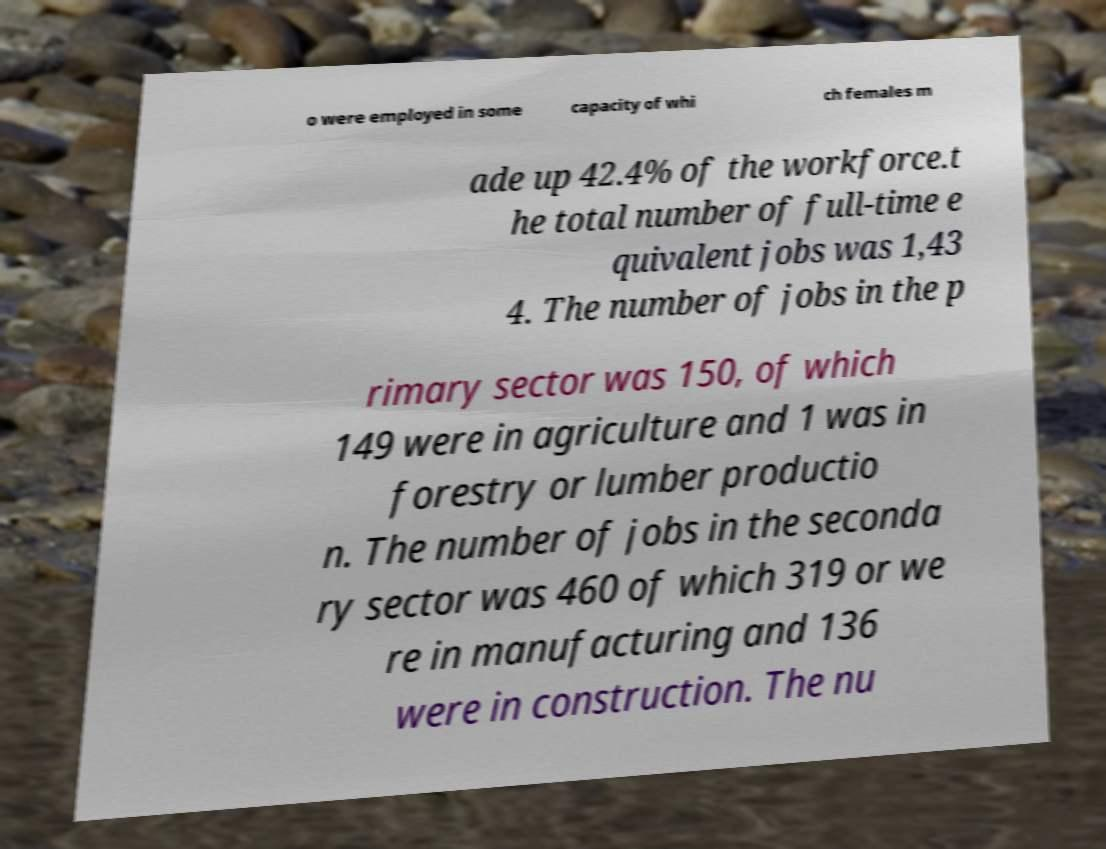Can you accurately transcribe the text from the provided image for me? o were employed in some capacity of whi ch females m ade up 42.4% of the workforce.t he total number of full-time e quivalent jobs was 1,43 4. The number of jobs in the p rimary sector was 150, of which 149 were in agriculture and 1 was in forestry or lumber productio n. The number of jobs in the seconda ry sector was 460 of which 319 or we re in manufacturing and 136 were in construction. The nu 